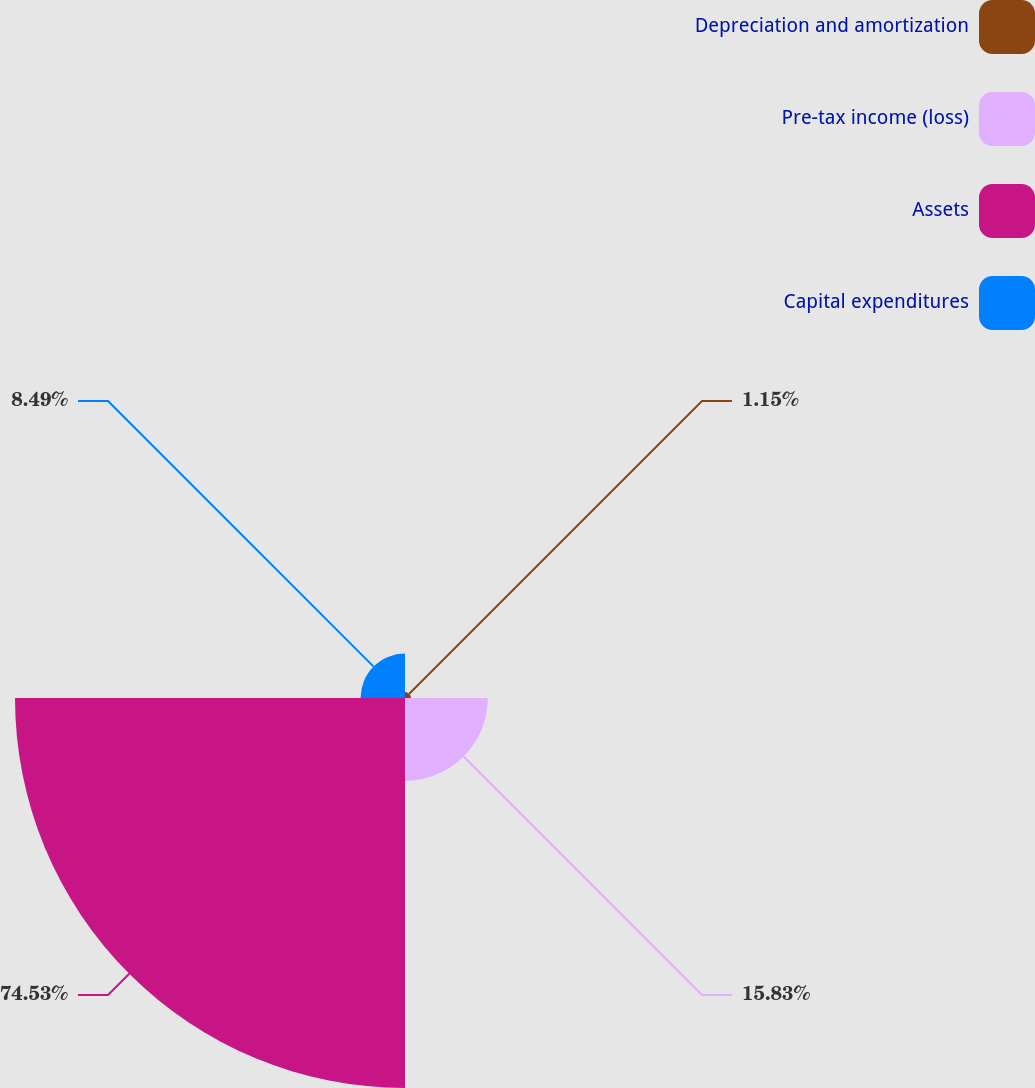Convert chart. <chart><loc_0><loc_0><loc_500><loc_500><pie_chart><fcel>Depreciation and amortization<fcel>Pre-tax income (loss)<fcel>Assets<fcel>Capital expenditures<nl><fcel>1.15%<fcel>15.83%<fcel>74.53%<fcel>8.49%<nl></chart> 